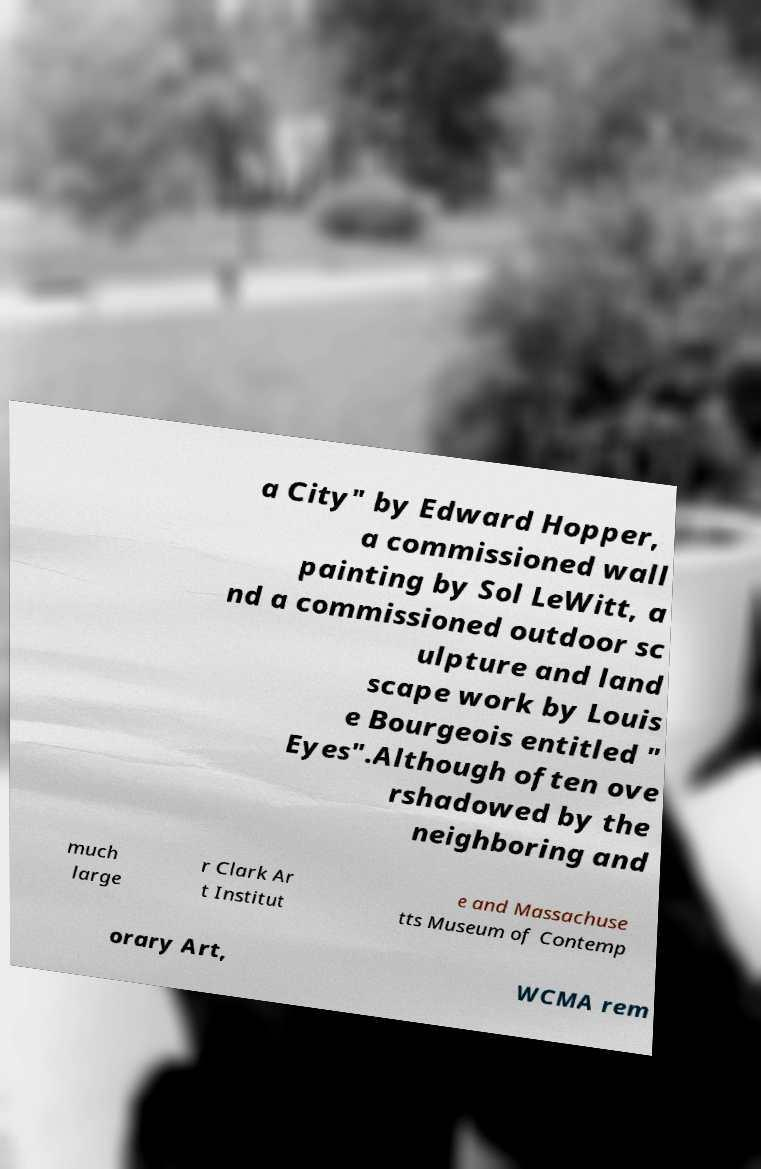Can you read and provide the text displayed in the image?This photo seems to have some interesting text. Can you extract and type it out for me? a City" by Edward Hopper, a commissioned wall painting by Sol LeWitt, a nd a commissioned outdoor sc ulpture and land scape work by Louis e Bourgeois entitled " Eyes".Although often ove rshadowed by the neighboring and much large r Clark Ar t Institut e and Massachuse tts Museum of Contemp orary Art, WCMA rem 